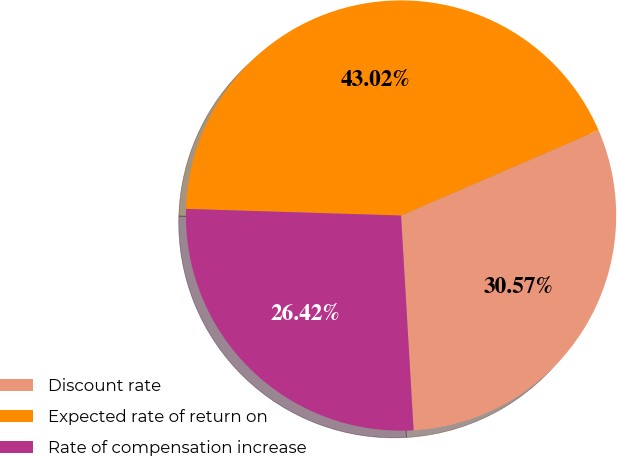<chart> <loc_0><loc_0><loc_500><loc_500><pie_chart><fcel>Discount rate<fcel>Expected rate of return on<fcel>Rate of compensation increase<nl><fcel>30.57%<fcel>43.02%<fcel>26.42%<nl></chart> 